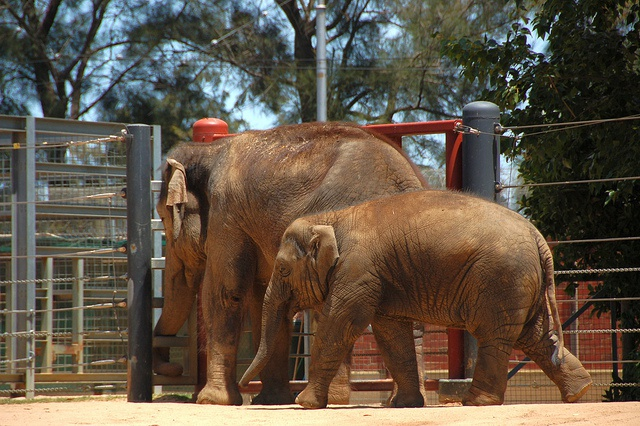Describe the objects in this image and their specific colors. I can see elephant in black, maroon, and gray tones and elephant in black, maroon, and gray tones in this image. 